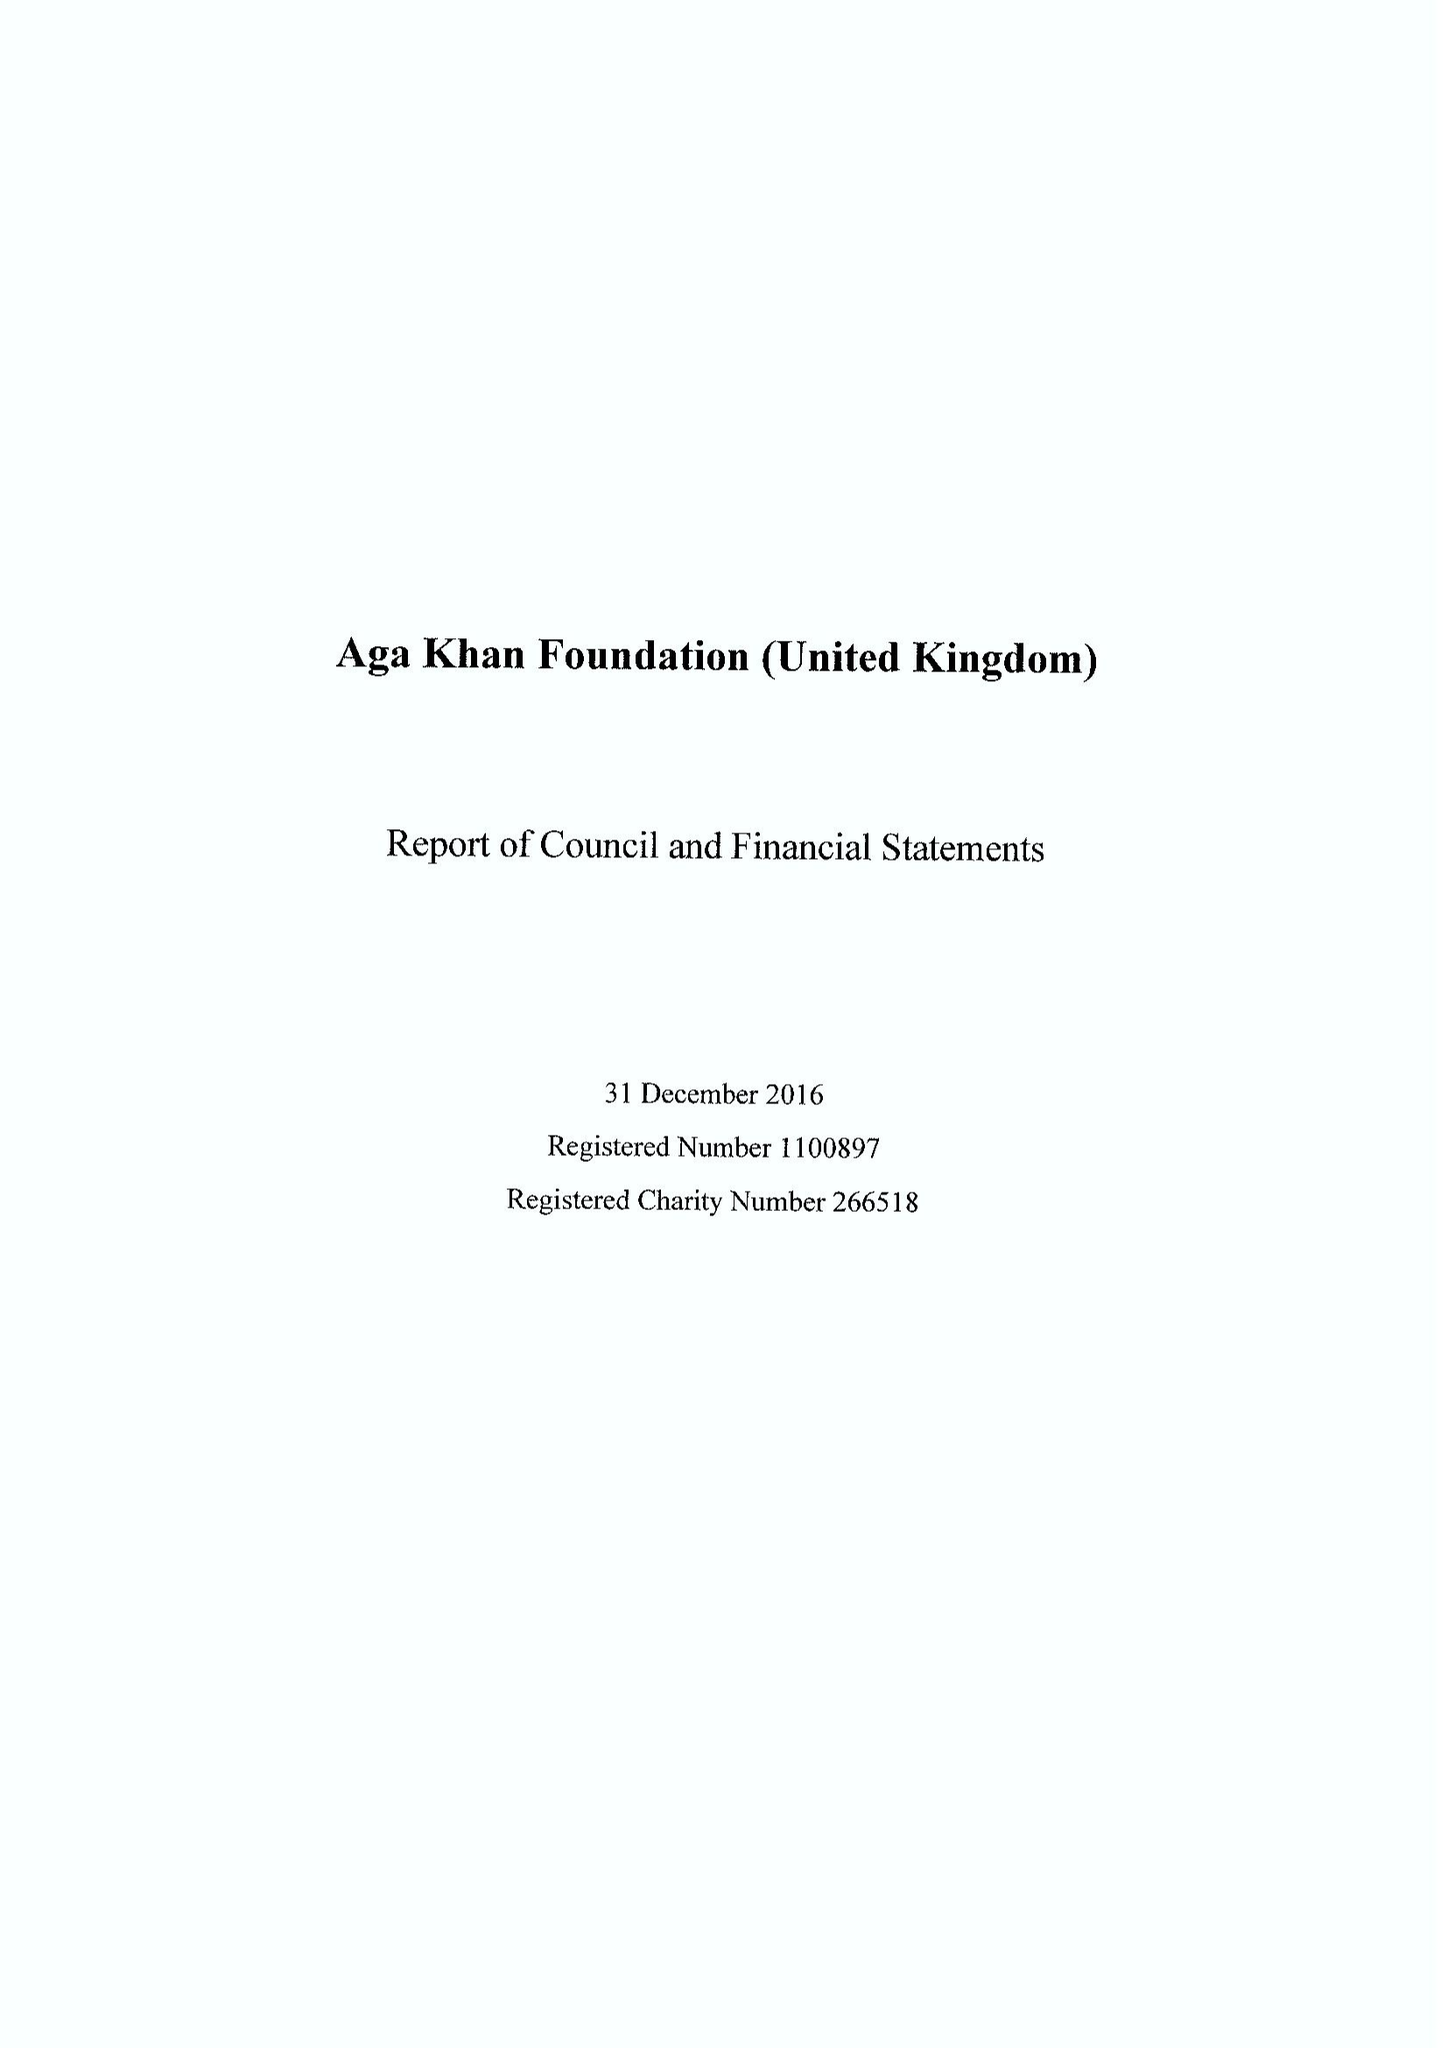What is the value for the address__postcode?
Answer the question using a single word or phrase. N1C 4DN 